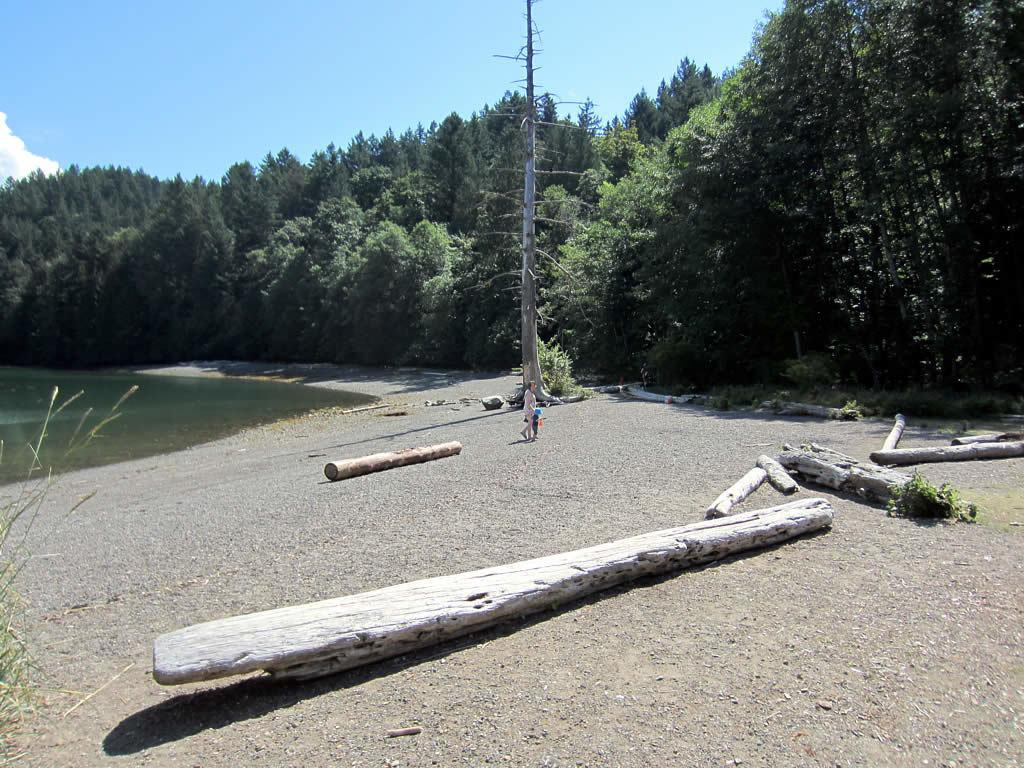What type of terrain is visible on the ground in the image? There are woods on the ground in the image. Can you describe the person in the image? There is a person standing in the image. What can be seen in the background of the image? There are trees, water, clouds, and the sky visible in the background of the image. What type of oranges can be seen hanging from the trees in the image? There are no oranges present in the image; it features woods on the ground and trees in the background. Can you describe the locket that the person is wearing in the image? There is no locket visible on the person in the image. 